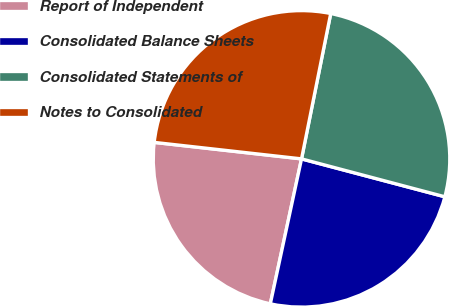Convert chart. <chart><loc_0><loc_0><loc_500><loc_500><pie_chart><fcel>Report of Independent<fcel>Consolidated Balance Sheets<fcel>Consolidated Statements of<fcel>Notes to Consolidated<nl><fcel>23.4%<fcel>24.26%<fcel>25.96%<fcel>26.38%<nl></chart> 